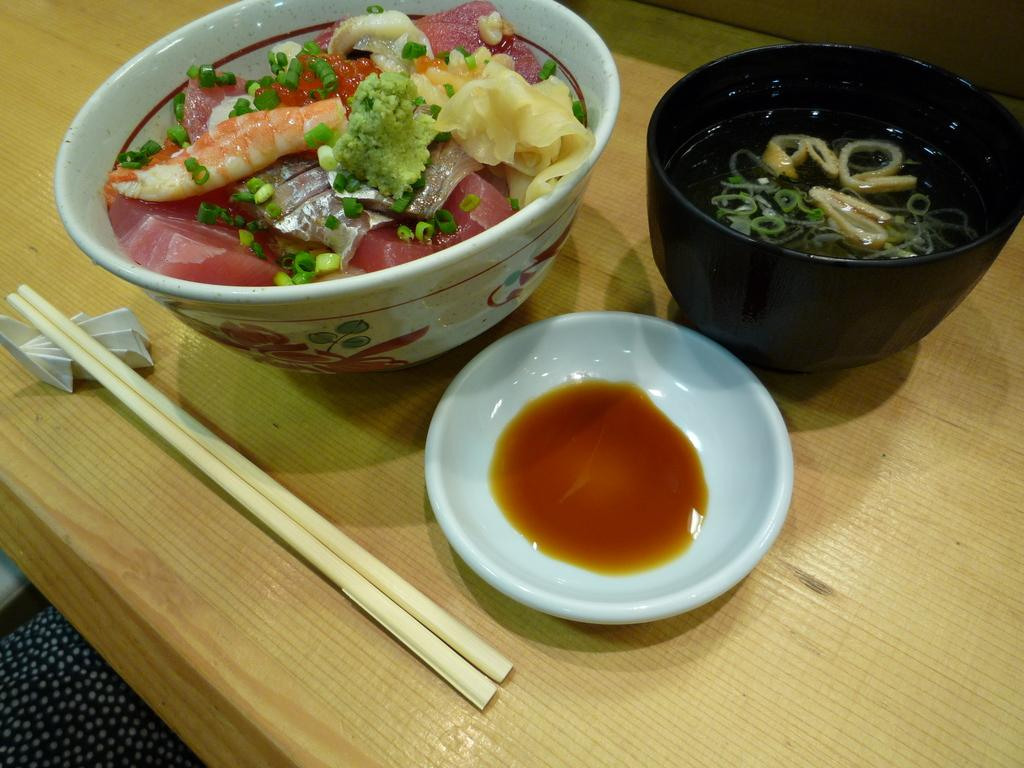What type of furniture is present in the image? There is a basic table in the image. What is on the table in the image? There is a bowl of food on the table. What utensils are visible in the image? There are spoons visible in the image. What type of current can be seen flowing through the field in the image? There is no current or field present in the image; it features a basic table with a bowl of food and spoons. 